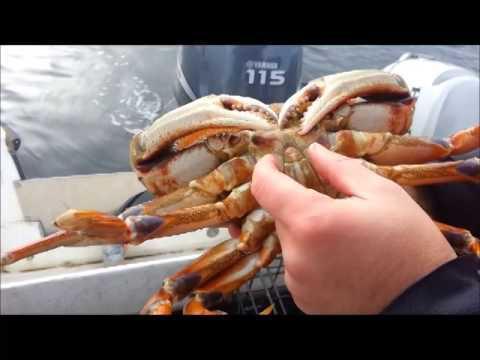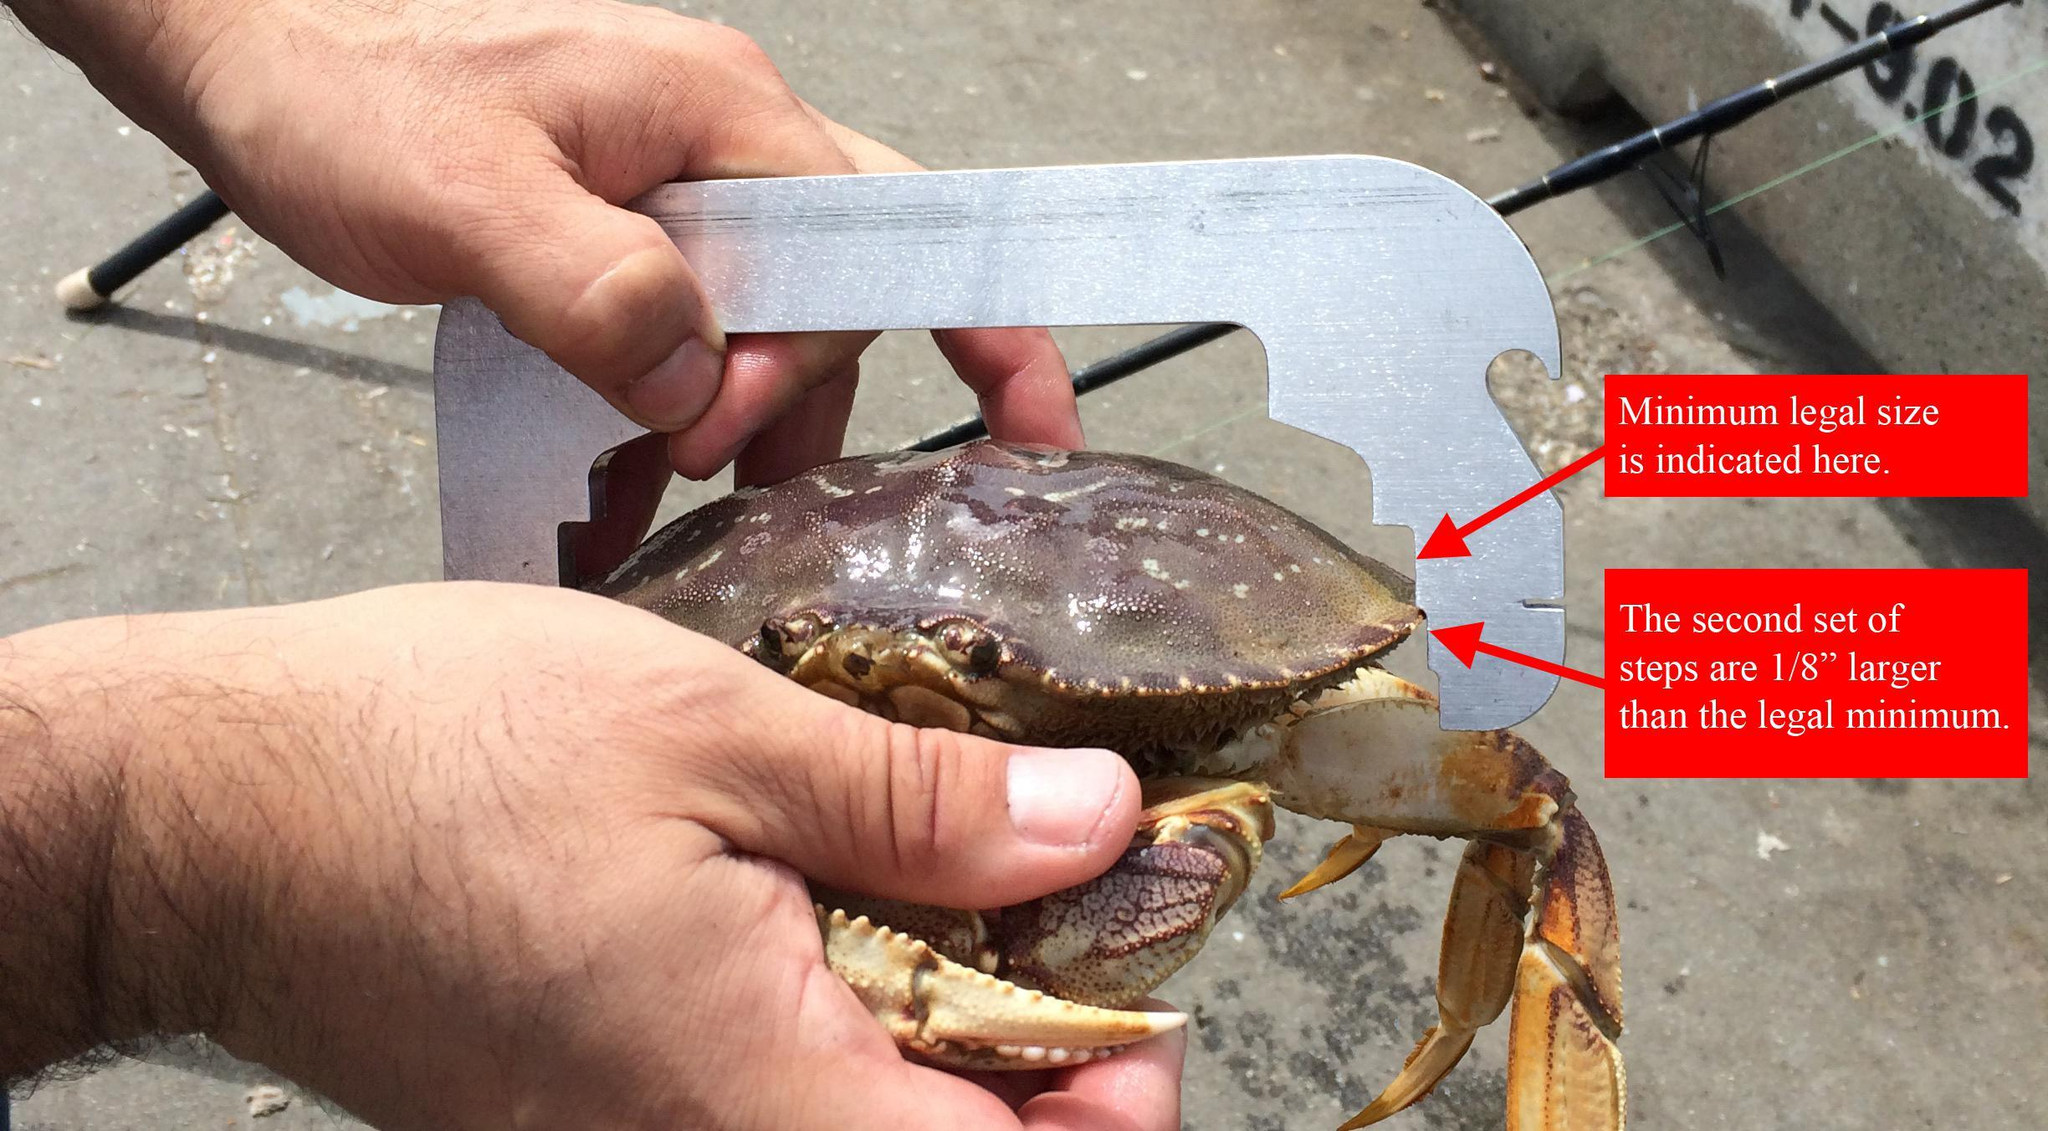The first image is the image on the left, the second image is the image on the right. Assess this claim about the two images: "In at least one image there is a round crab trap that is holding at least 15 crab while being held by a person in a boat.". Correct or not? Answer yes or no. No. The first image is the image on the left, the second image is the image on the right. Examine the images to the left and right. Is the description "There are crabs inside a cage." accurate? Answer yes or no. No. 